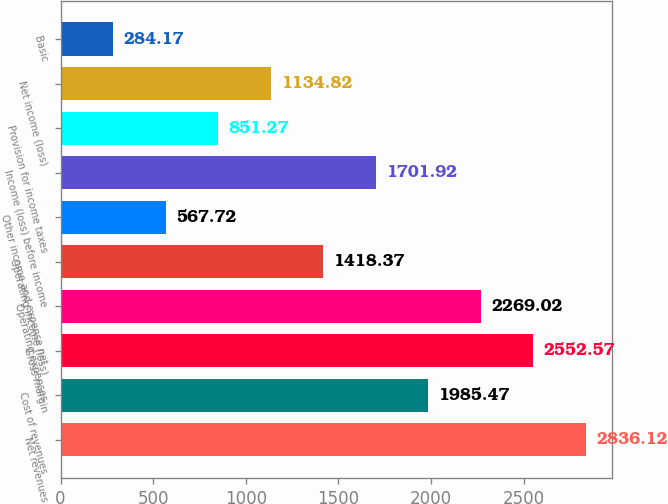Convert chart to OTSL. <chart><loc_0><loc_0><loc_500><loc_500><bar_chart><fcel>Net revenues<fcel>Cost of revenues<fcel>Gross margin<fcel>Operating expenses<fcel>Operating income (loss)<fcel>Other income and expense net<fcel>Income (loss) before income<fcel>Provision for income taxes<fcel>Net income (loss)<fcel>Basic<nl><fcel>2836.12<fcel>1985.47<fcel>2552.57<fcel>2269.02<fcel>1418.37<fcel>567.72<fcel>1701.92<fcel>851.27<fcel>1134.82<fcel>284.17<nl></chart> 